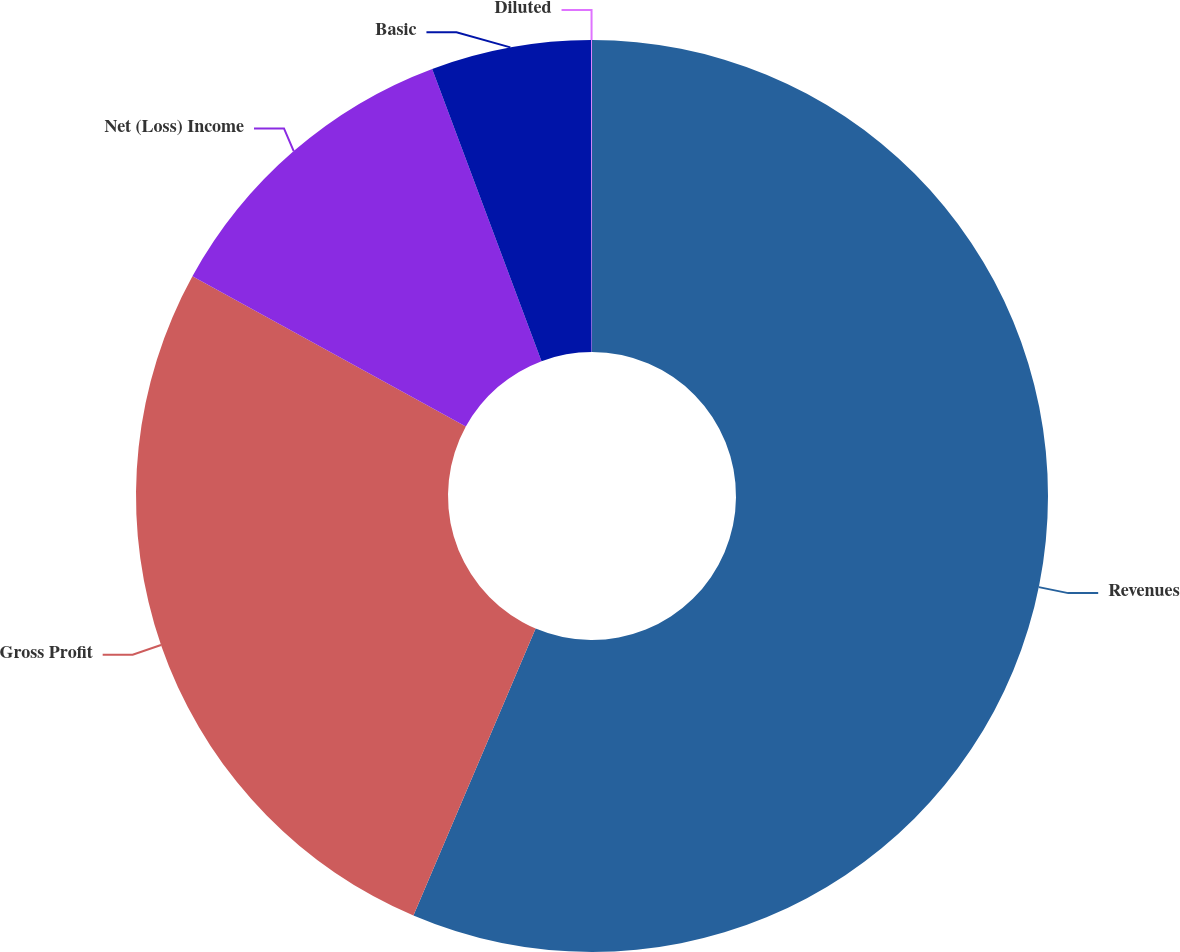Convert chart. <chart><loc_0><loc_0><loc_500><loc_500><pie_chart><fcel>Revenues<fcel>Gross Profit<fcel>Net (Loss) Income<fcel>Basic<fcel>Diluted<nl><fcel>56.41%<fcel>26.6%<fcel>11.3%<fcel>5.67%<fcel>0.03%<nl></chart> 